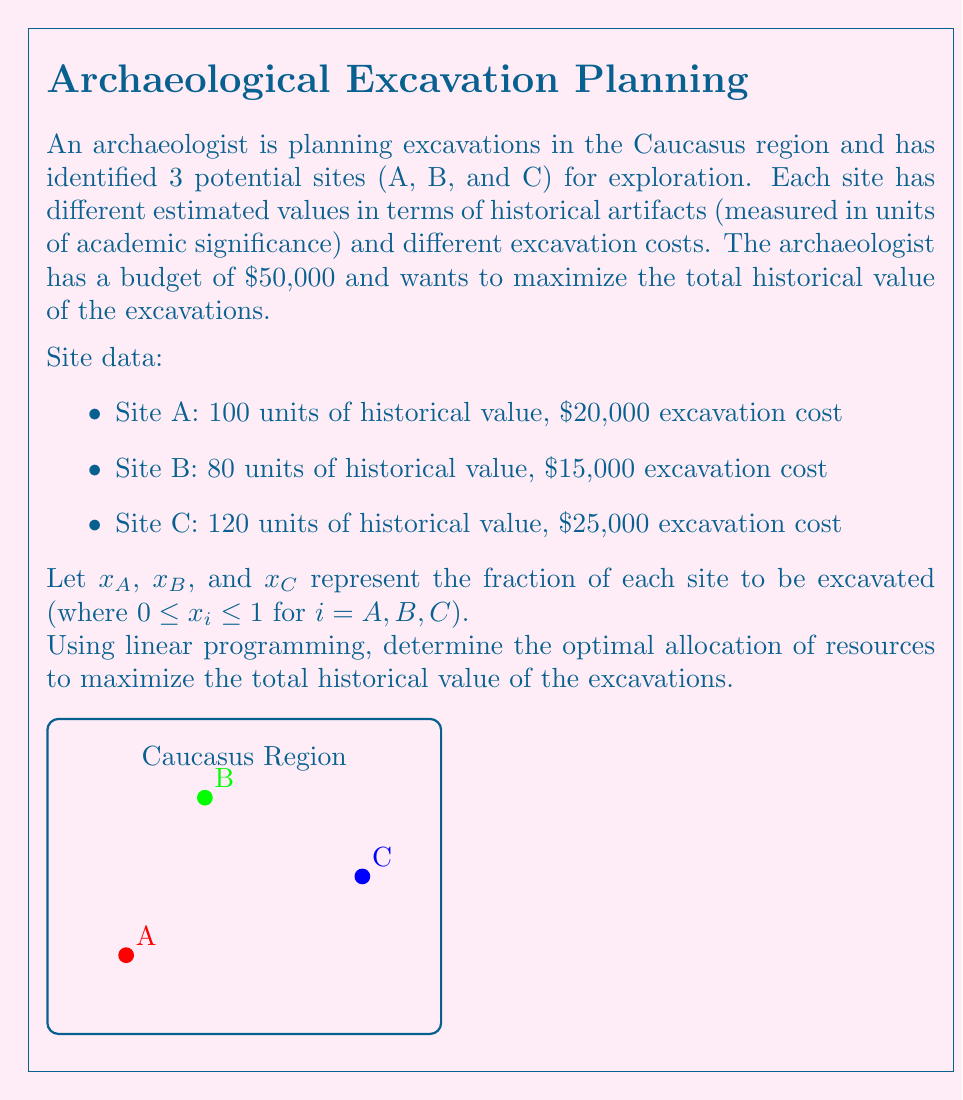Can you solve this math problem? To solve this linear programming problem, we'll follow these steps:

1) Formulate the objective function:
   Maximize $Z = 100x_A + 80x_B + 120x_C$

2) Identify the constraints:
   Budget constraint: $20000x_A + 15000x_B + 25000x_C \leq 50000$
   Fraction constraints: $0 \leq x_A \leq 1$, $0 \leq x_B \leq 1$, $0 \leq x_C \leq 1$

3) Set up the linear programming problem:
   Maximize $Z = 100x_A + 80x_B + 120x_C$
   Subject to:
   $20000x_A + 15000x_B + 25000x_C \leq 50000$
   $0 \leq x_A \leq 1$
   $0 \leq x_B \leq 1$
   $0 \leq x_C \leq 1$

4) Solve using the simplex method or a linear programming solver.

5) The optimal solution is:
   $x_A = 1$ (fully excavate Site A)
   $x_B = 1$ (fully excavate Site B)
   $x_C = 0.4$ (excavate 40% of Site C)

6) Calculate the maximum historical value:
   $Z = 100(1) + 80(1) + 120(0.4) = 228$ units of historical value

7) Verify the budget constraint:
   $20000(1) + 15000(1) + 25000(0.4) = 45000 \leq 50000$

Therefore, the optimal allocation is to fully excavate Sites A and B, and partially excavate Site C (40%), resulting in a maximum historical value of 228 units while staying within the budget.
Answer: $x_A = 1$, $x_B = 1$, $x_C = 0.4$; Maximum historical value: 228 units 